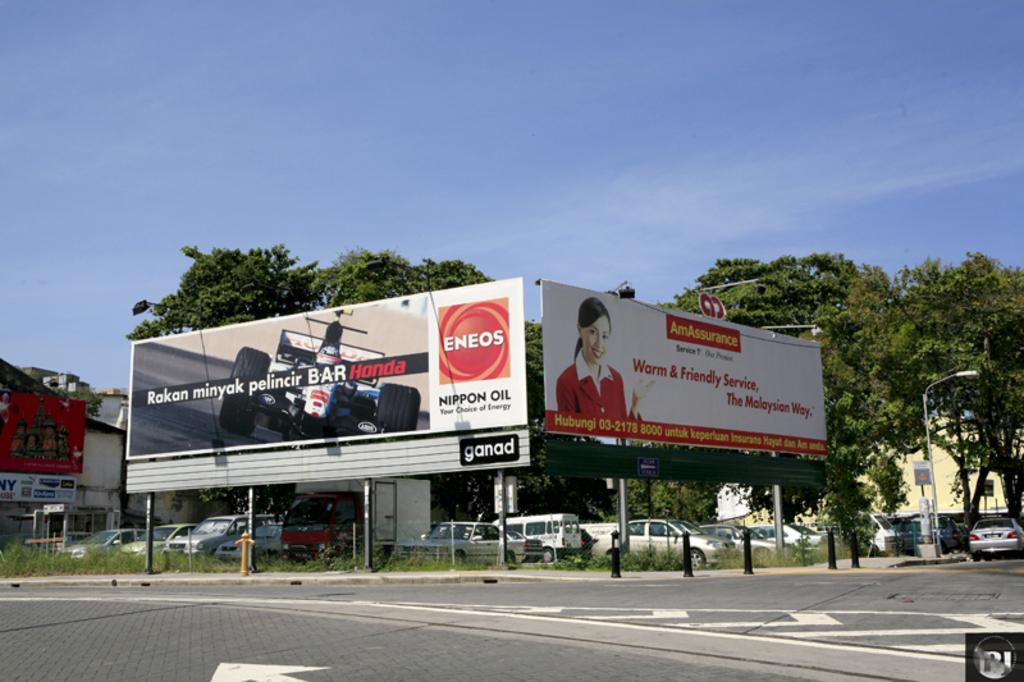<image>
Provide a brief description of the given image. Two billboards at an intersection with an ad for ENEOS racing oil and AmAssurance. 